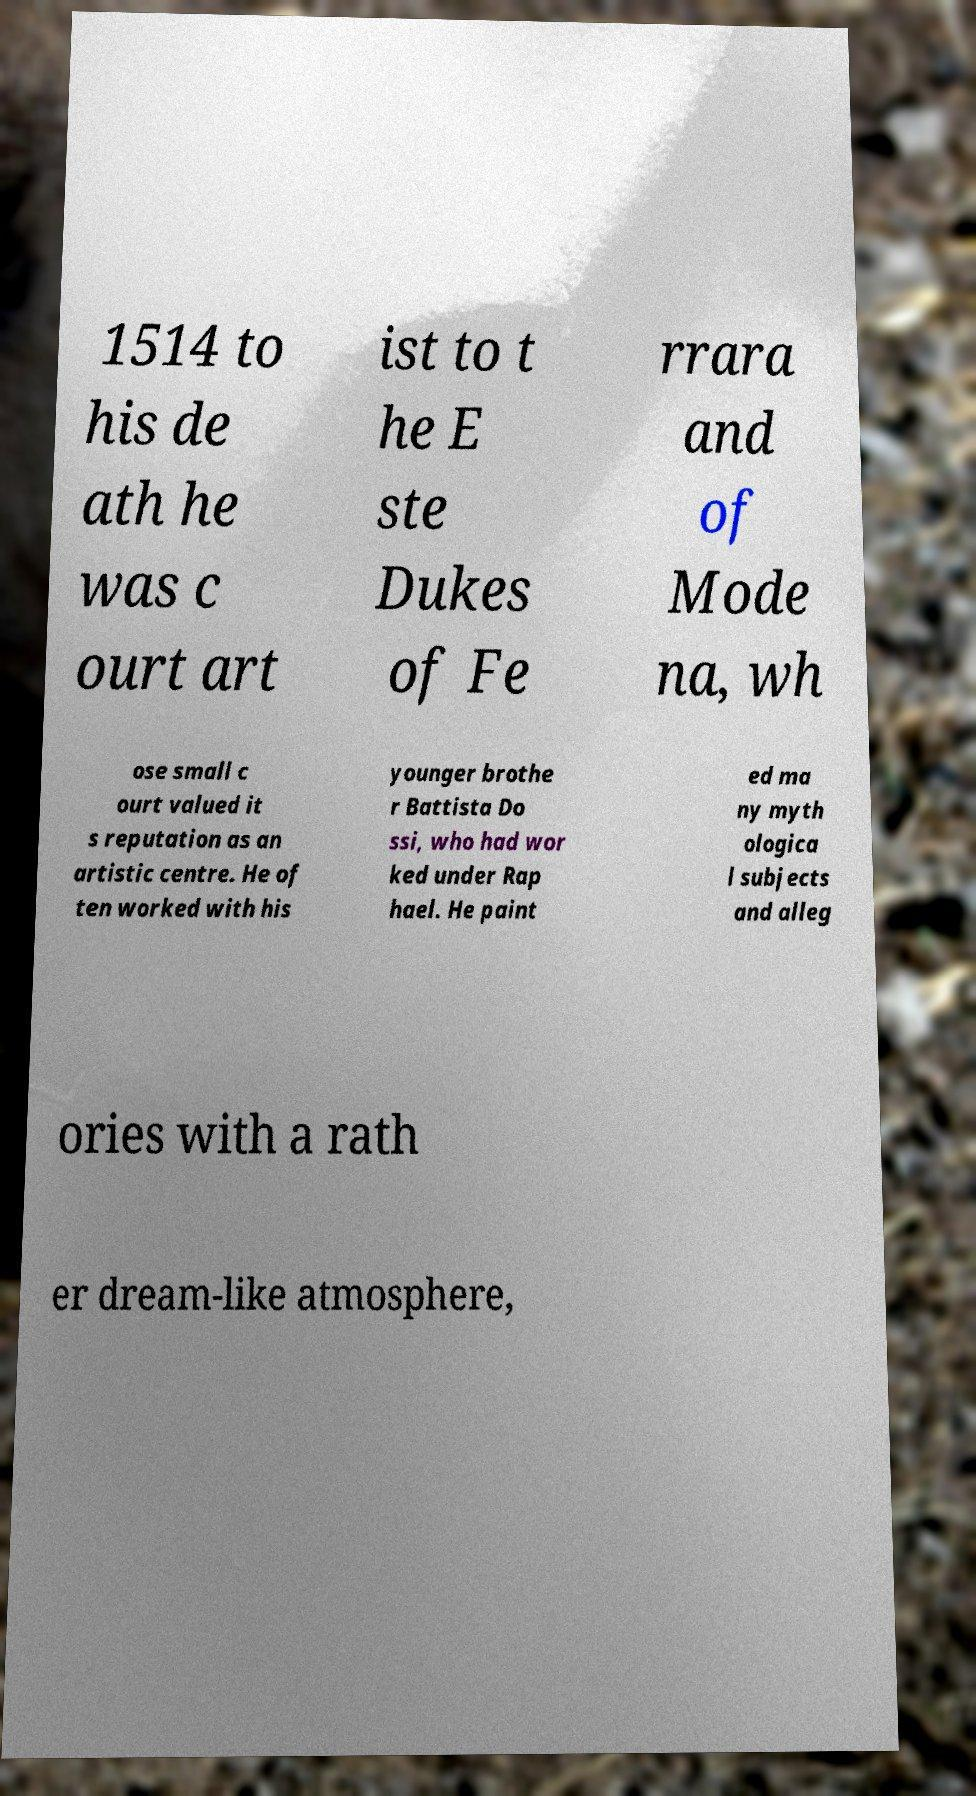Can you accurately transcribe the text from the provided image for me? 1514 to his de ath he was c ourt art ist to t he E ste Dukes of Fe rrara and of Mode na, wh ose small c ourt valued it s reputation as an artistic centre. He of ten worked with his younger brothe r Battista Do ssi, who had wor ked under Rap hael. He paint ed ma ny myth ologica l subjects and alleg ories with a rath er dream-like atmosphere, 